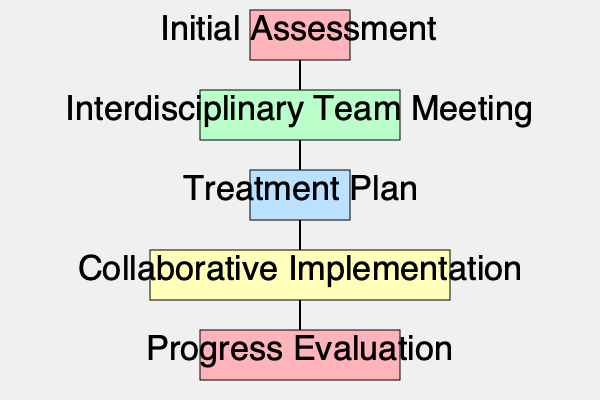In the collaborative addiction treatment program flowchart, which stage directly precedes the development of the treatment plan and emphasizes the importance of interdisciplinary approaches? To answer this question, we need to analyze the flowchart of the collaborative addiction treatment program step by step:

1. The flowchart begins with the "Initial Assessment" stage at the top.

2. Following the Initial Assessment, we see an arrow pointing to the "Interdisciplinary Team Meeting" stage.

3. After the Interdisciplinary Team Meeting, the next stage in the flowchart is the "Treatment Plan" development.

4. The subsequent stages are "Collaborative Implementation" and "Progress Evaluation."

By examining the sequence of stages, we can see that the stage directly preceding the Treatment Plan is the Interdisciplinary Team Meeting. This stage is crucial as it brings together professionals from various disciplines to discuss the client's case and contribute their expertise to inform the treatment plan.

The Interdisciplinary Team Meeting stage emphasizes the importance of interdisciplinary approaches in addiction treatment by:

a) Facilitating collaboration among different professionals (e.g., social workers, psychologists, medical doctors, and counselors).
b) Ensuring a comprehensive understanding of the client's needs from multiple perspectives.
c) Allowing for the integration of diverse treatment modalities and strategies.
d) Promoting a holistic approach to addiction treatment that addresses various aspects of the client's life and health.

This stage aligns with the social worker's value of collaboration and interdisciplinary approaches in addiction treatment, as it provides a platform for different professionals to work together in developing the most effective treatment plan for the client.
Answer: Interdisciplinary Team Meeting 